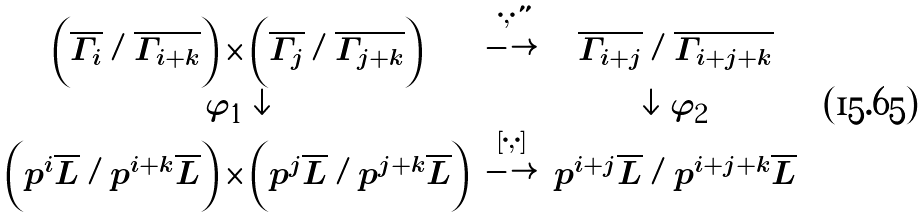<formula> <loc_0><loc_0><loc_500><loc_500>\begin{array} { c c c } \left ( \overline { \Gamma _ { i } } / \overline { \Gamma _ { i + k } } \right ) \times \left ( \overline { \Gamma _ { j } } / \overline { \Gamma _ { j + k } } \right ) & \stackrel { \left \{ \cdot , \cdot \right \} } { \longrightarrow } & \overline { \Gamma _ { i + j } } / \overline { \Gamma _ { i + j + k } } \\ \varphi _ { 1 } \downarrow & & \downarrow \varphi _ { 2 } \\ \left ( p ^ { i } \overline { L } / p ^ { i + k } \overline { L } \right ) \times \left ( p ^ { j } \overline { L } / p ^ { j + k } \overline { L } \right ) & \stackrel { \left [ \cdot , \cdot \right ] } { \longrightarrow } & p ^ { i + j } \overline { L } / p ^ { i + j + k } \overline { L } \end{array}</formula> 